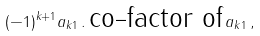Convert formula to latex. <formula><loc_0><loc_0><loc_500><loc_500>( - 1 ) ^ { k + 1 } a _ { k 1 } \, . \, \text {co-factor of} \, a _ { k 1 } \, ,</formula> 